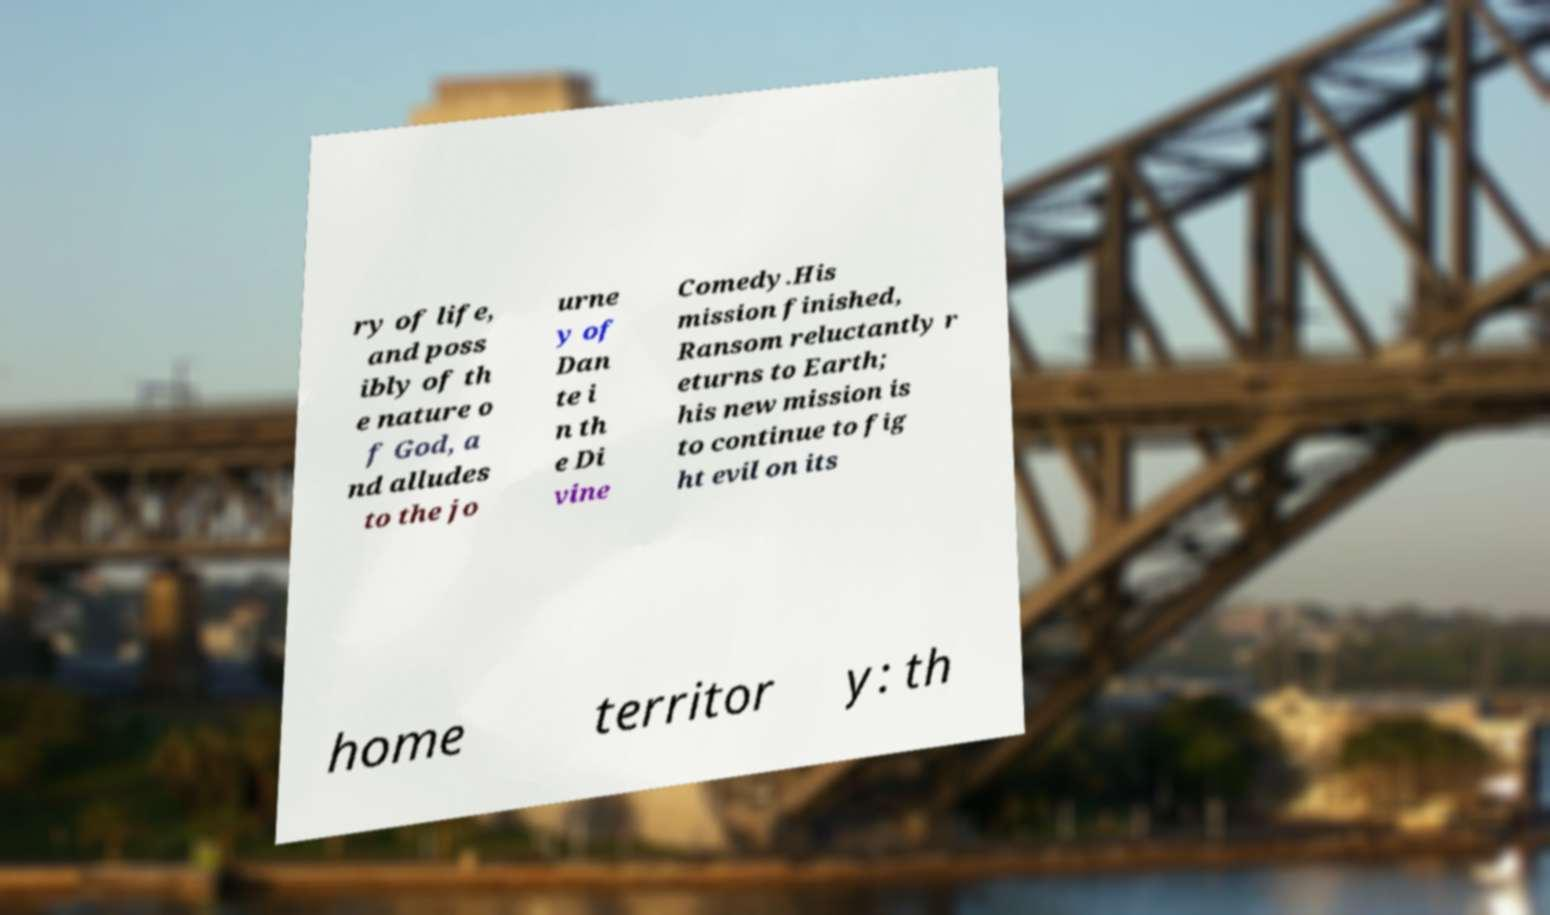Please identify and transcribe the text found in this image. ry of life, and poss ibly of th e nature o f God, a nd alludes to the jo urne y of Dan te i n th e Di vine Comedy.His mission finished, Ransom reluctantly r eturns to Earth; his new mission is to continue to fig ht evil on its home territor y: th 